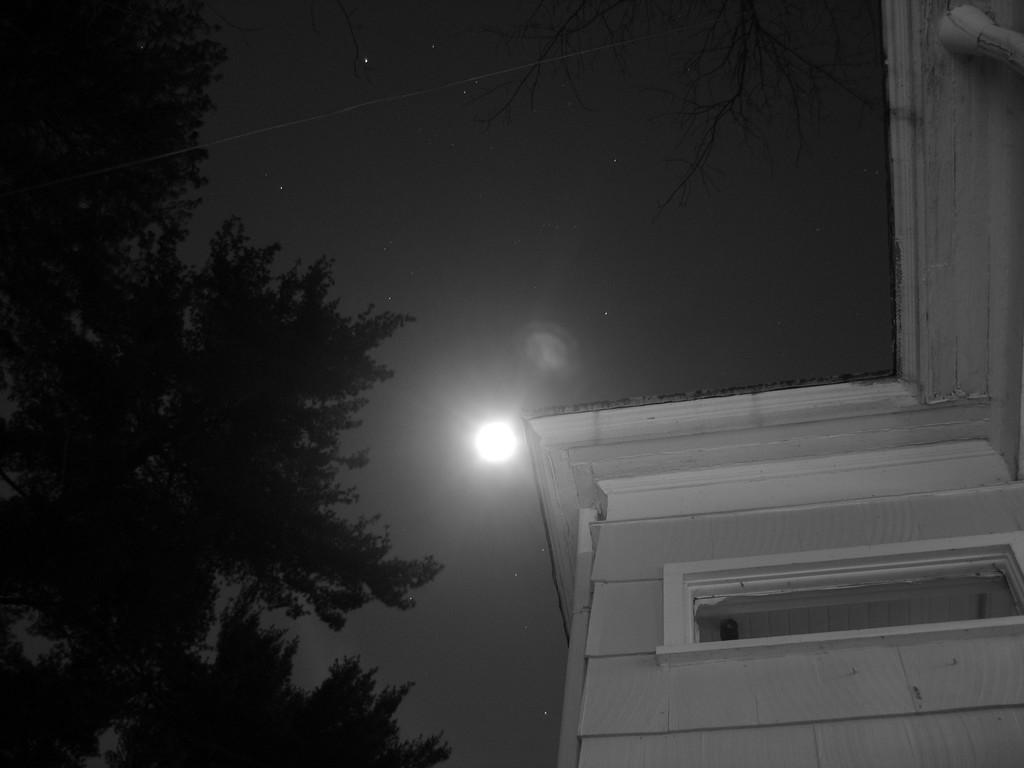What is the main structure in the front of the image? There is a building in the front of the image. What type of vegetation can be seen on the left side of the image? There are trees on the left side of the image. What celestial body is visible in the sky? The moon is visible in the sky. Can you see a locket hanging from the tree on the left side of the image? There is no locket visible in the image; only trees are present on the left side. 